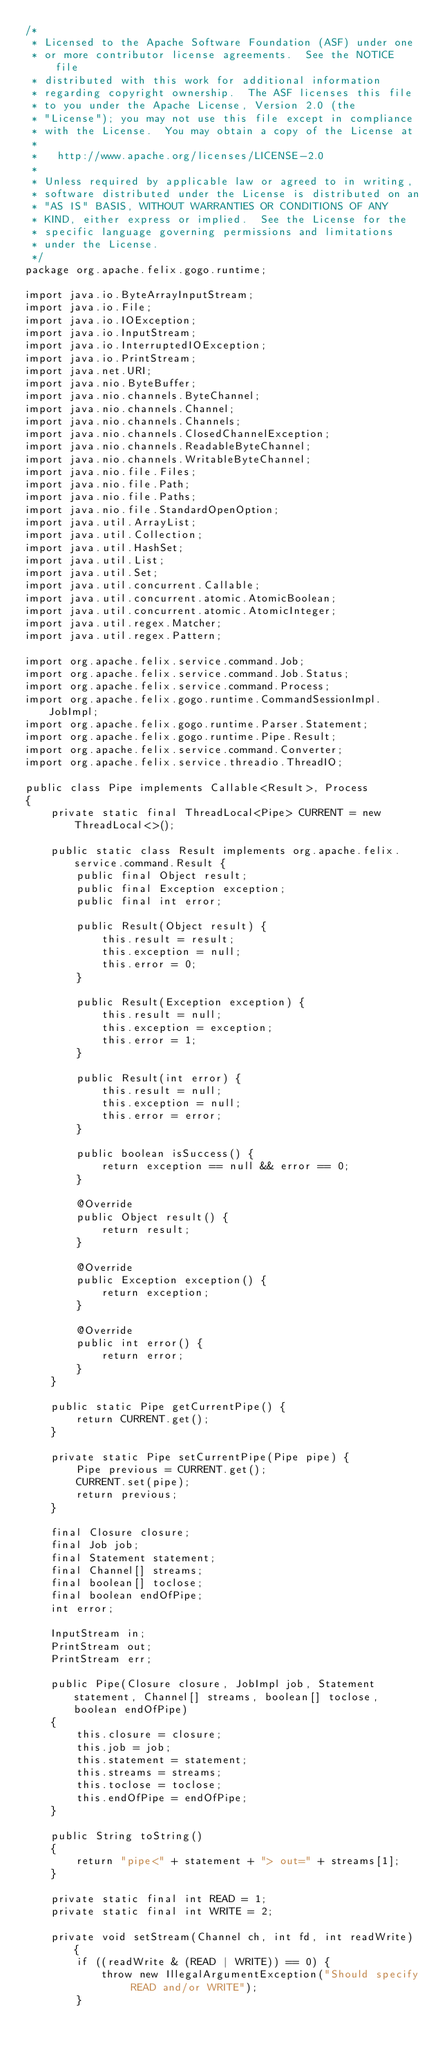Convert code to text. <code><loc_0><loc_0><loc_500><loc_500><_Java_>/*
 * Licensed to the Apache Software Foundation (ASF) under one
 * or more contributor license agreements.  See the NOTICE file
 * distributed with this work for additional information
 * regarding copyright ownership.  The ASF licenses this file
 * to you under the Apache License, Version 2.0 (the
 * "License"); you may not use this file except in compliance
 * with the License.  You may obtain a copy of the License at
 *
 *   http://www.apache.org/licenses/LICENSE-2.0
 *
 * Unless required by applicable law or agreed to in writing,
 * software distributed under the License is distributed on an
 * "AS IS" BASIS, WITHOUT WARRANTIES OR CONDITIONS OF ANY
 * KIND, either express or implied.  See the License for the
 * specific language governing permissions and limitations
 * under the License.
 */
package org.apache.felix.gogo.runtime;

import java.io.ByteArrayInputStream;
import java.io.File;
import java.io.IOException;
import java.io.InputStream;
import java.io.InterruptedIOException;
import java.io.PrintStream;
import java.net.URI;
import java.nio.ByteBuffer;
import java.nio.channels.ByteChannel;
import java.nio.channels.Channel;
import java.nio.channels.Channels;
import java.nio.channels.ClosedChannelException;
import java.nio.channels.ReadableByteChannel;
import java.nio.channels.WritableByteChannel;
import java.nio.file.Files;
import java.nio.file.Path;
import java.nio.file.Paths;
import java.nio.file.StandardOpenOption;
import java.util.ArrayList;
import java.util.Collection;
import java.util.HashSet;
import java.util.List;
import java.util.Set;
import java.util.concurrent.Callable;
import java.util.concurrent.atomic.AtomicBoolean;
import java.util.concurrent.atomic.AtomicInteger;
import java.util.regex.Matcher;
import java.util.regex.Pattern;

import org.apache.felix.service.command.Job;
import org.apache.felix.service.command.Job.Status;
import org.apache.felix.service.command.Process;
import org.apache.felix.gogo.runtime.CommandSessionImpl.JobImpl;
import org.apache.felix.gogo.runtime.Parser.Statement;
import org.apache.felix.gogo.runtime.Pipe.Result;
import org.apache.felix.service.command.Converter;
import org.apache.felix.service.threadio.ThreadIO;

public class Pipe implements Callable<Result>, Process
{
    private static final ThreadLocal<Pipe> CURRENT = new ThreadLocal<>();

    public static class Result implements org.apache.felix.service.command.Result {
        public final Object result;
        public final Exception exception;
        public final int error;

        public Result(Object result) {
            this.result = result;
            this.exception = null;
            this.error = 0;
        }

        public Result(Exception exception) {
            this.result = null;
            this.exception = exception;
            this.error = 1;
        }

        public Result(int error) {
            this.result = null;
            this.exception = null;
            this.error = error;
        }

        public boolean isSuccess() {
            return exception == null && error == 0;
        }

        @Override
        public Object result() {
            return result;
        }

        @Override
        public Exception exception() {
            return exception;
        }

        @Override
        public int error() {
            return error;
        }
    }

    public static Pipe getCurrentPipe() {
        return CURRENT.get();
    }

    private static Pipe setCurrentPipe(Pipe pipe) {
        Pipe previous = CURRENT.get();
        CURRENT.set(pipe);
        return previous;
    }

    final Closure closure;
    final Job job;
    final Statement statement;
    final Channel[] streams;
    final boolean[] toclose;
    final boolean endOfPipe;
    int error;

    InputStream in;
    PrintStream out;
    PrintStream err;

    public Pipe(Closure closure, JobImpl job, Statement statement, Channel[] streams, boolean[] toclose, boolean endOfPipe)
    {
        this.closure = closure;
        this.job = job;
        this.statement = statement;
        this.streams = streams;
        this.toclose = toclose;
        this.endOfPipe = endOfPipe;
    }

    public String toString()
    {
        return "pipe<" + statement + "> out=" + streams[1];
    }

    private static final int READ = 1;
    private static final int WRITE = 2;

    private void setStream(Channel ch, int fd, int readWrite) {
        if ((readWrite & (READ | WRITE)) == 0) {
            throw new IllegalArgumentException("Should specify READ and/or WRITE");
        }</code> 